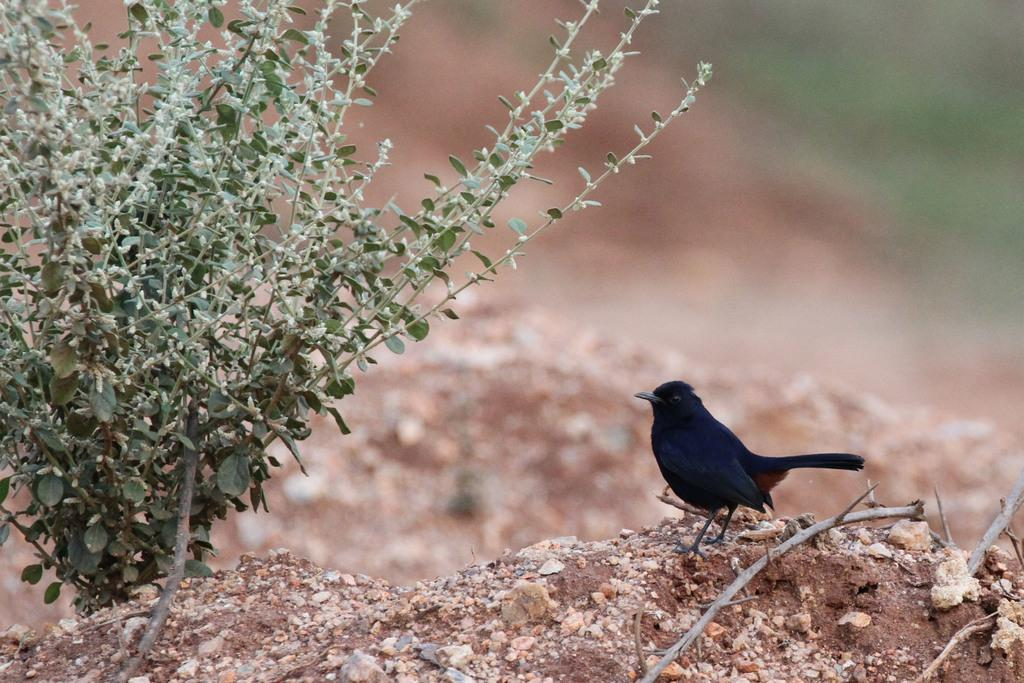What type of bird is in the image? There is a black color bird in the image. What else can be seen at the bottom of the image? There is a plant at the bottom of the image. What type of vest is the bird wearing in the image? There is no vest present on the bird in the image. What type of oil can be seen dripping from the plant in the image? There is no oil present in the image, and the plant does not appear to be dripping anything. 